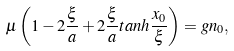<formula> <loc_0><loc_0><loc_500><loc_500>\mu \left ( 1 - 2 \frac { \xi } { a } + 2 \frac { \xi } { a } t a n h \frac { x _ { 0 } } { \xi } \right ) = g n _ { 0 } ,</formula> 